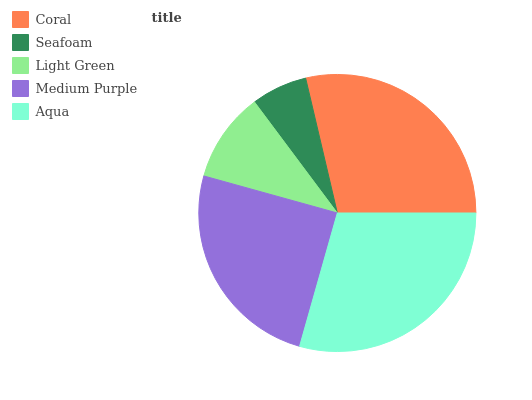Is Seafoam the minimum?
Answer yes or no. Yes. Is Aqua the maximum?
Answer yes or no. Yes. Is Light Green the minimum?
Answer yes or no. No. Is Light Green the maximum?
Answer yes or no. No. Is Light Green greater than Seafoam?
Answer yes or no. Yes. Is Seafoam less than Light Green?
Answer yes or no. Yes. Is Seafoam greater than Light Green?
Answer yes or no. No. Is Light Green less than Seafoam?
Answer yes or no. No. Is Medium Purple the high median?
Answer yes or no. Yes. Is Medium Purple the low median?
Answer yes or no. Yes. Is Seafoam the high median?
Answer yes or no. No. Is Seafoam the low median?
Answer yes or no. No. 